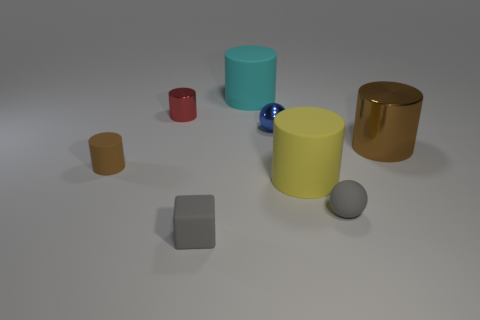Is the brown cylinder left of the gray block made of the same material as the gray sphere?
Make the answer very short. Yes. What number of big yellow cylinders have the same material as the red cylinder?
Give a very brief answer. 0. Are there more big brown metallic objects that are right of the large cyan cylinder than cyan cylinders?
Offer a very short reply. No. There is another cylinder that is the same color as the small rubber cylinder; what is its size?
Make the answer very short. Large. Are there any large blue shiny objects of the same shape as the tiny red thing?
Your answer should be very brief. No. What number of things are yellow things or tiny purple metallic balls?
Provide a succinct answer. 1. What number of cylinders are to the right of the gray rubber object that is in front of the tiny sphere right of the blue thing?
Your answer should be compact. 3. What material is the gray object that is the same shape as the blue metal thing?
Provide a short and direct response. Rubber. There is a big thing that is both on the left side of the tiny gray ball and behind the large yellow object; what is its material?
Provide a short and direct response. Rubber. Are there fewer yellow rubber objects left of the cyan object than gray things that are behind the small matte cube?
Provide a short and direct response. Yes. 